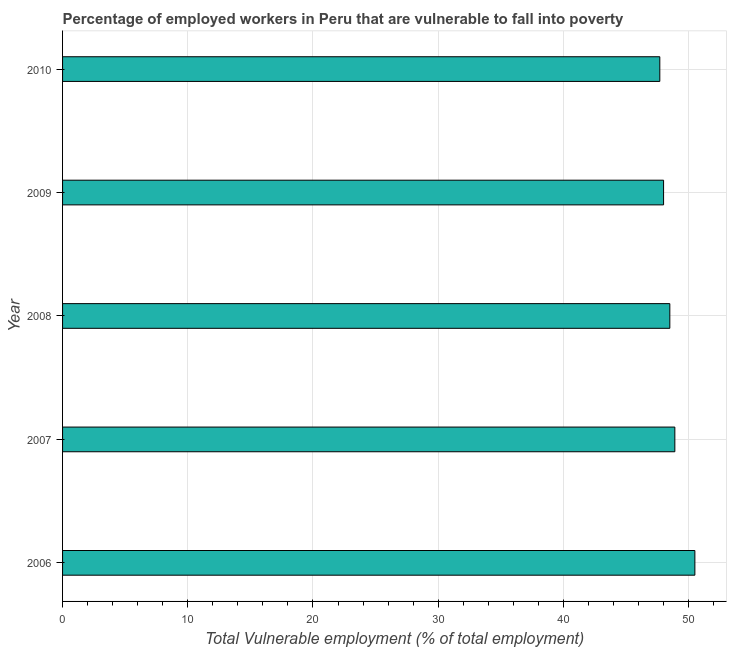Does the graph contain any zero values?
Offer a very short reply. No. Does the graph contain grids?
Give a very brief answer. Yes. What is the title of the graph?
Your response must be concise. Percentage of employed workers in Peru that are vulnerable to fall into poverty. What is the label or title of the X-axis?
Your answer should be compact. Total Vulnerable employment (% of total employment). What is the total vulnerable employment in 2007?
Give a very brief answer. 48.9. Across all years, what is the maximum total vulnerable employment?
Provide a short and direct response. 50.5. Across all years, what is the minimum total vulnerable employment?
Give a very brief answer. 47.7. In which year was the total vulnerable employment maximum?
Provide a succinct answer. 2006. In which year was the total vulnerable employment minimum?
Your answer should be very brief. 2010. What is the sum of the total vulnerable employment?
Provide a short and direct response. 243.6. What is the difference between the total vulnerable employment in 2006 and 2010?
Ensure brevity in your answer.  2.8. What is the average total vulnerable employment per year?
Your response must be concise. 48.72. What is the median total vulnerable employment?
Your answer should be very brief. 48.5. In how many years, is the total vulnerable employment greater than 24 %?
Ensure brevity in your answer.  5. What is the ratio of the total vulnerable employment in 2006 to that in 2010?
Your response must be concise. 1.06. Is the difference between the total vulnerable employment in 2008 and 2010 greater than the difference between any two years?
Your response must be concise. No. How many years are there in the graph?
Your answer should be compact. 5. Are the values on the major ticks of X-axis written in scientific E-notation?
Keep it short and to the point. No. What is the Total Vulnerable employment (% of total employment) of 2006?
Offer a terse response. 50.5. What is the Total Vulnerable employment (% of total employment) of 2007?
Your answer should be compact. 48.9. What is the Total Vulnerable employment (% of total employment) of 2008?
Your answer should be very brief. 48.5. What is the Total Vulnerable employment (% of total employment) of 2009?
Keep it short and to the point. 48. What is the Total Vulnerable employment (% of total employment) of 2010?
Offer a very short reply. 47.7. What is the difference between the Total Vulnerable employment (% of total employment) in 2006 and 2010?
Make the answer very short. 2.8. What is the difference between the Total Vulnerable employment (% of total employment) in 2007 and 2009?
Your answer should be compact. 0.9. What is the difference between the Total Vulnerable employment (% of total employment) in 2008 and 2009?
Offer a terse response. 0.5. What is the ratio of the Total Vulnerable employment (% of total employment) in 2006 to that in 2007?
Offer a very short reply. 1.03. What is the ratio of the Total Vulnerable employment (% of total employment) in 2006 to that in 2008?
Offer a terse response. 1.04. What is the ratio of the Total Vulnerable employment (% of total employment) in 2006 to that in 2009?
Your response must be concise. 1.05. What is the ratio of the Total Vulnerable employment (% of total employment) in 2006 to that in 2010?
Provide a succinct answer. 1.06. What is the ratio of the Total Vulnerable employment (% of total employment) in 2007 to that in 2010?
Provide a short and direct response. 1.02. 